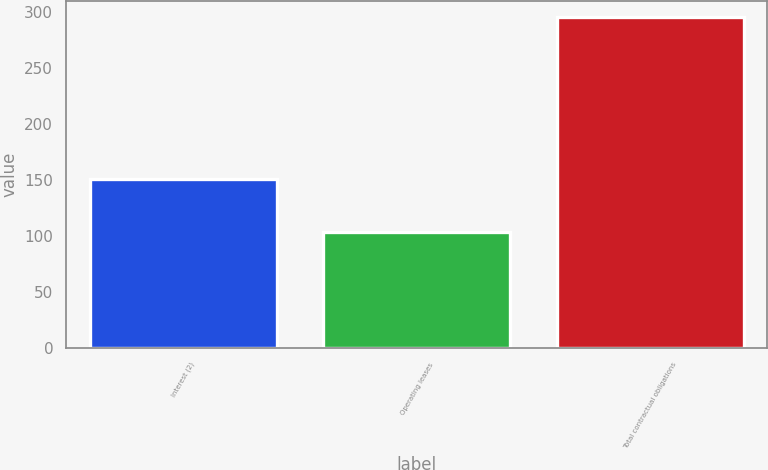<chart> <loc_0><loc_0><loc_500><loc_500><bar_chart><fcel>Interest (2)<fcel>Operating leases<fcel>Total contractual obligations<nl><fcel>151<fcel>104<fcel>295.4<nl></chart> 